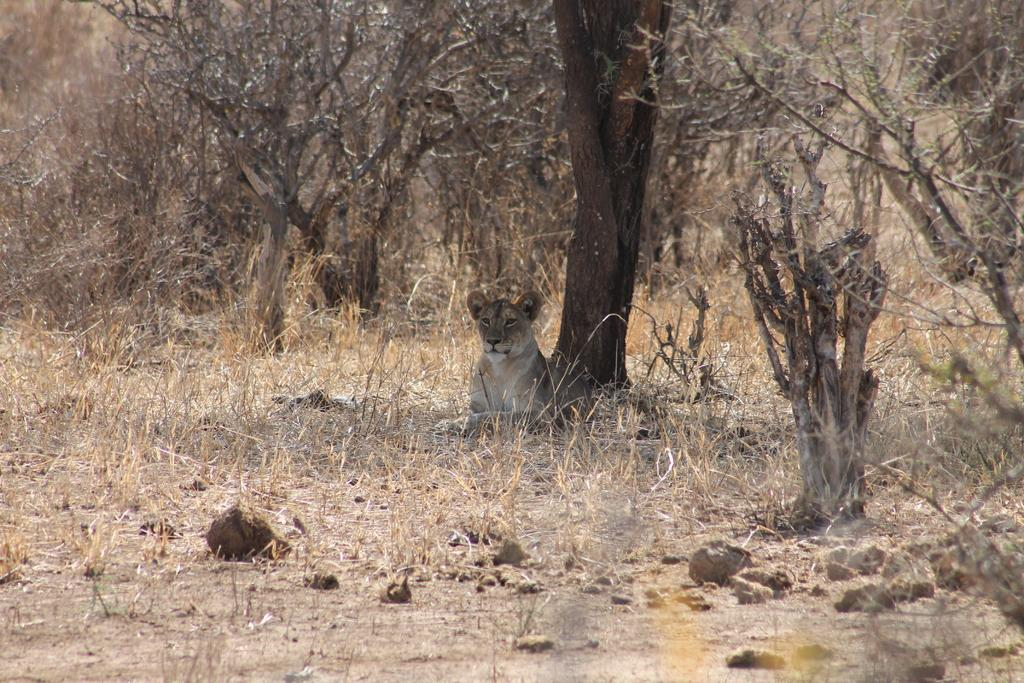What animal is the main subject of the image? There is a tiger in the image. Where is the tiger located in the image? The tiger is under a tree. What else can be seen in the background of the image? There are additional trees in the background of the image. What type of pie is being served at the tiger's birthday party in the image? There is no pie or birthday party present in the image; it features a tiger under a tree with additional trees in the background. 